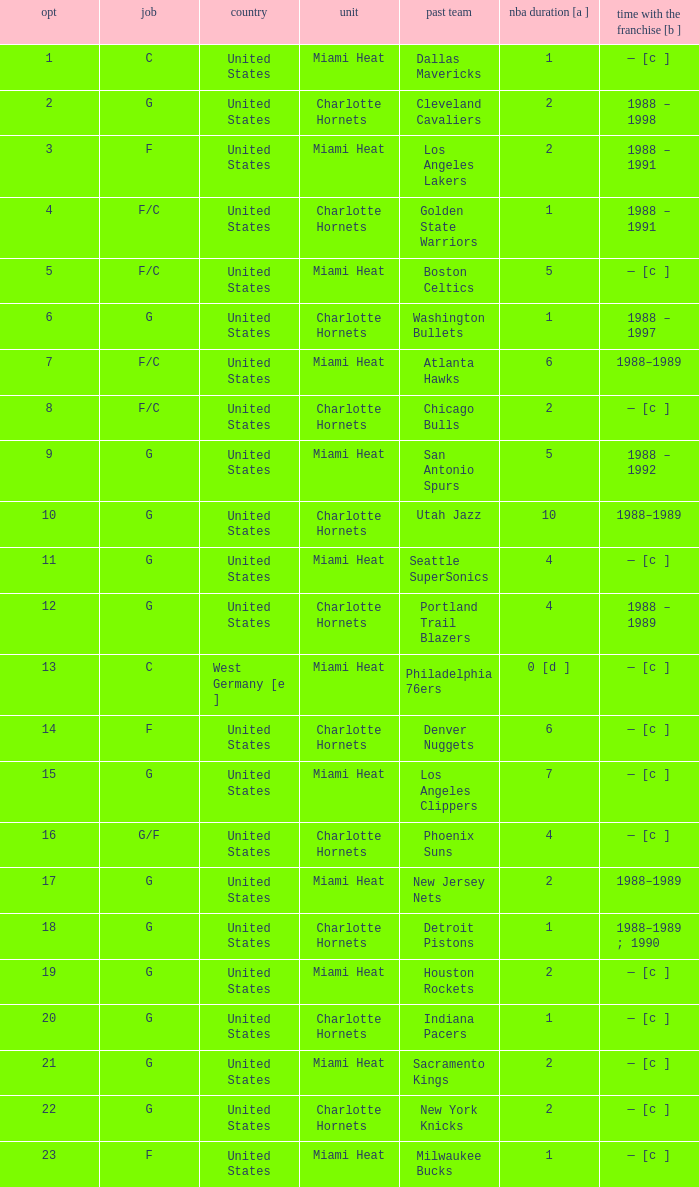What is the previous team of the player with 4 NBA years and a pick less than 16? Seattle SuperSonics, Portland Trail Blazers. 